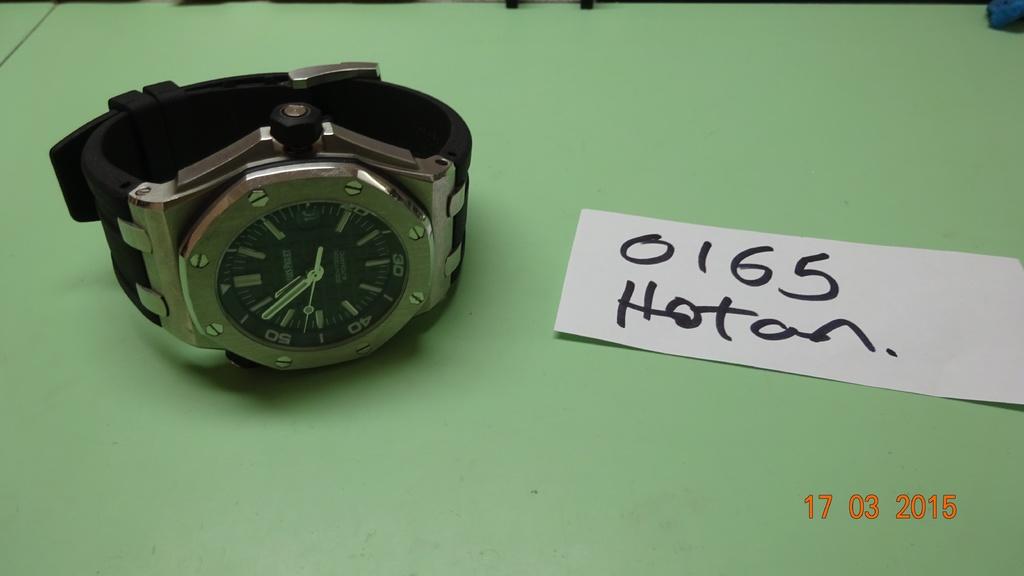What time is displayed on the watch?
Your answer should be very brief. 10:54. 